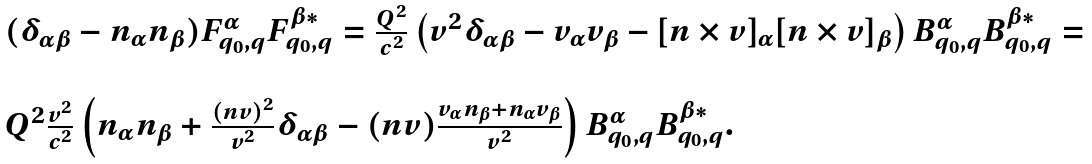<formula> <loc_0><loc_0><loc_500><loc_500>\begin{array} { l } ( \delta _ { \alpha \beta } - n _ { \alpha } n _ { \beta } ) F ^ { \alpha } _ { q _ { 0 } , { q } } F ^ { \beta * } _ { q _ { 0 } , { q } } = \frac { Q ^ { 2 } } { c ^ { 2 } } \left ( v ^ { 2 } \delta _ { \alpha \beta } - v _ { \alpha } v _ { \beta } - [ n \times v ] _ { \alpha } [ n \times v ] _ { \beta } \right ) B ^ { \alpha } _ { q _ { 0 } , { q } } B ^ { \beta * } _ { q _ { 0 } , { q } } = \\ \\ Q ^ { 2 } \frac { v ^ { 2 } } { c ^ { 2 } } \left ( n _ { \alpha } n _ { \beta } + \frac { ( { n v } ) ^ { 2 } } { v ^ { 2 } } \delta _ { \alpha \beta } - ( { n v } ) \frac { v _ { \alpha } n _ { \beta } + n _ { \alpha } v _ { \beta } } { v ^ { 2 } } \right ) B ^ { \alpha } _ { q _ { 0 } , { q } } B ^ { \beta * } _ { q _ { 0 } , { q } } . \end{array}</formula> 